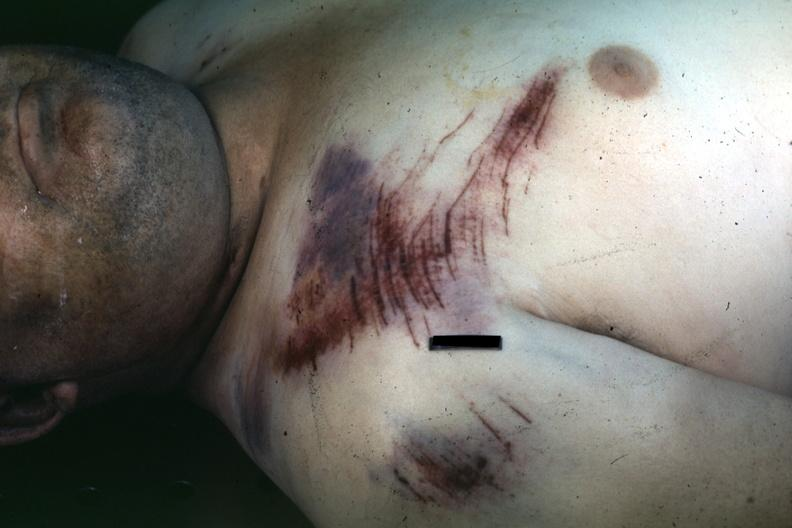what is present?
Answer the question using a single word or phrase. Contusion and abrasion focus 